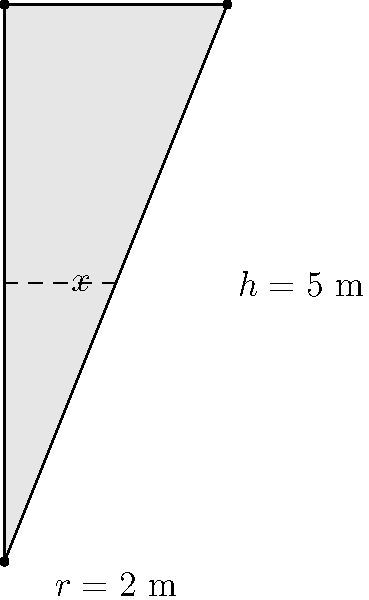A conical water tank has a height of 5 meters and a radius of 2 meters at the top. Calculate the work done in pumping all the water out of the tank to its top edge. Assume the density of water is 1000 kg/m³ and the acceleration due to gravity is 9.8 m/s². Express your answer in joules. To solve this problem, we'll follow these steps:

1) First, we need to set up the integral for the work done. The general formula is:

   $$W = \int_{0}^{h} \rho g (h-x) \cdot \pi r(x)^2 dx$$

   Where $\rho$ is the density of water, $g$ is the acceleration due to gravity, $h$ is the height of the tank, and $r(x)$ is the radius at height $x$.

2) In a cone, the radius at any height $x$ is proportional to the height:

   $$r(x) = \frac{R}{h}x$$

   Where $R$ is the radius at the top of the cone.

3) Substituting this into our integral:

   $$W = \int_{0}^{5} 1000 \cdot 9.8 \cdot (5-x) \cdot \pi (\frac{2}{5}x)^2 dx$$

4) Simplify the constants:

   $$W = 9800\pi (\frac{4}{25}) \int_{0}^{5} (5-x) \cdot x^2 dx$$

5) Expand the integrand:

   $$W = 1568\pi \int_{0}^{5} (5x^2 - x^3) dx$$

6) Integrate:

   $$W = 1568\pi [\frac{5x^3}{3} - \frac{x^4}{4}]_{0}^{5}$$

7) Evaluate the integral:

   $$W = 1568\pi (\frac{625}{3} - \frac{625}{4})$$

8) Simplify:

   $$W = 1568\pi (\frac{2500}{12} - \frac{1875}{12}) = 1568\pi \cdot \frac{625}{12}$$

9) Calculate the final result:

   $$W = 256,916.67 \text{ J}$$
Answer: 256,916.67 J 